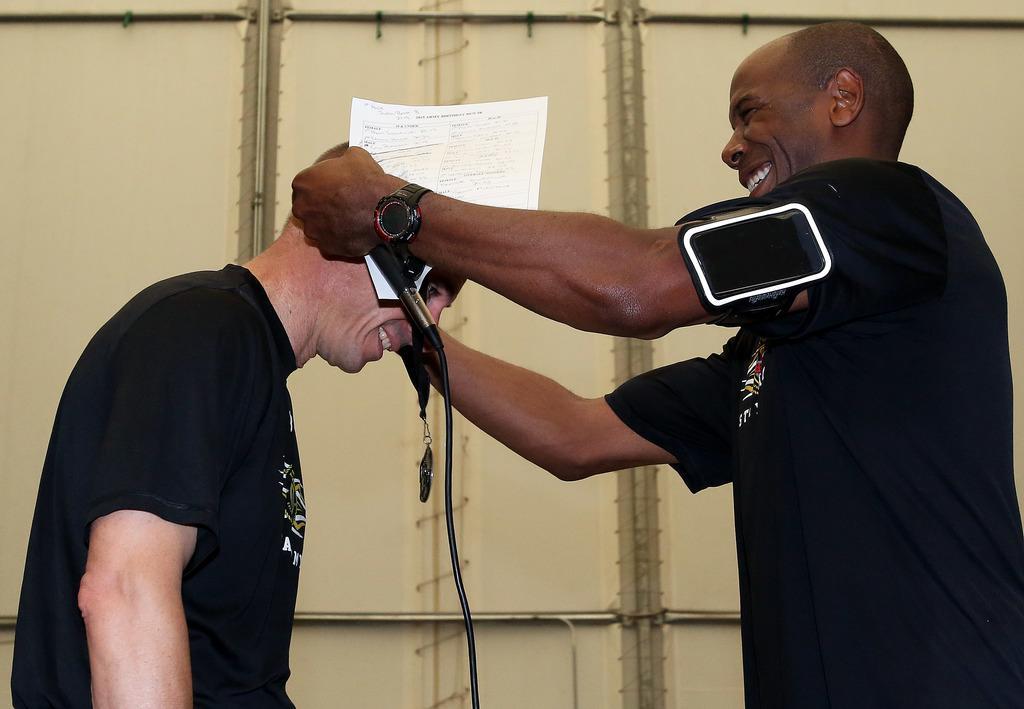Please provide a concise description of this image. In the image we can see there are two men who are standing and the man is holding mic his hand and a paper. 